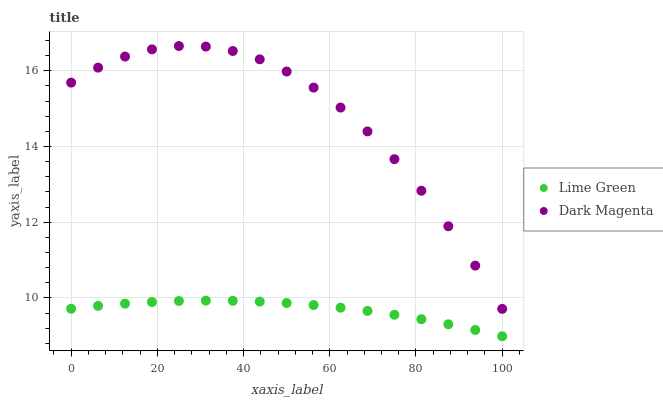Does Lime Green have the minimum area under the curve?
Answer yes or no. Yes. Does Dark Magenta have the maximum area under the curve?
Answer yes or no. Yes. Does Dark Magenta have the minimum area under the curve?
Answer yes or no. No. Is Lime Green the smoothest?
Answer yes or no. Yes. Is Dark Magenta the roughest?
Answer yes or no. Yes. Is Dark Magenta the smoothest?
Answer yes or no. No. Does Lime Green have the lowest value?
Answer yes or no. Yes. Does Dark Magenta have the lowest value?
Answer yes or no. No. Does Dark Magenta have the highest value?
Answer yes or no. Yes. Is Lime Green less than Dark Magenta?
Answer yes or no. Yes. Is Dark Magenta greater than Lime Green?
Answer yes or no. Yes. Does Lime Green intersect Dark Magenta?
Answer yes or no. No. 